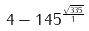<formula> <loc_0><loc_0><loc_500><loc_500>4 - 1 4 5 ^ { \frac { \sqrt { 3 3 5 } } { 1 } }</formula> 